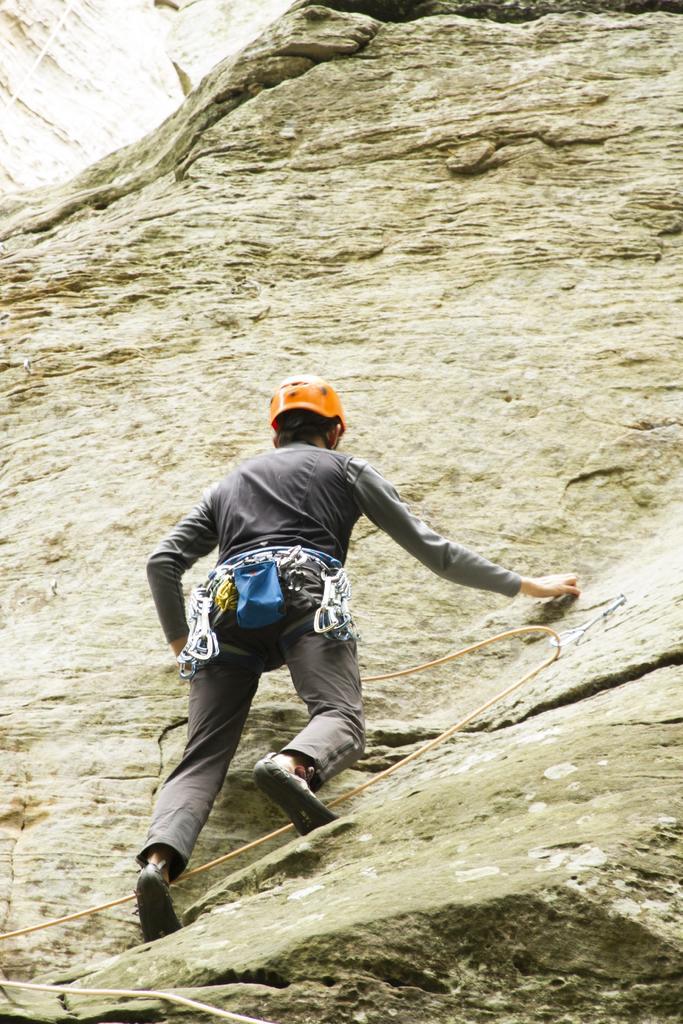Can you describe this image briefly? In this picture we can see a person is climbing the hill with the help of ropes, and the person wore a helmet. 